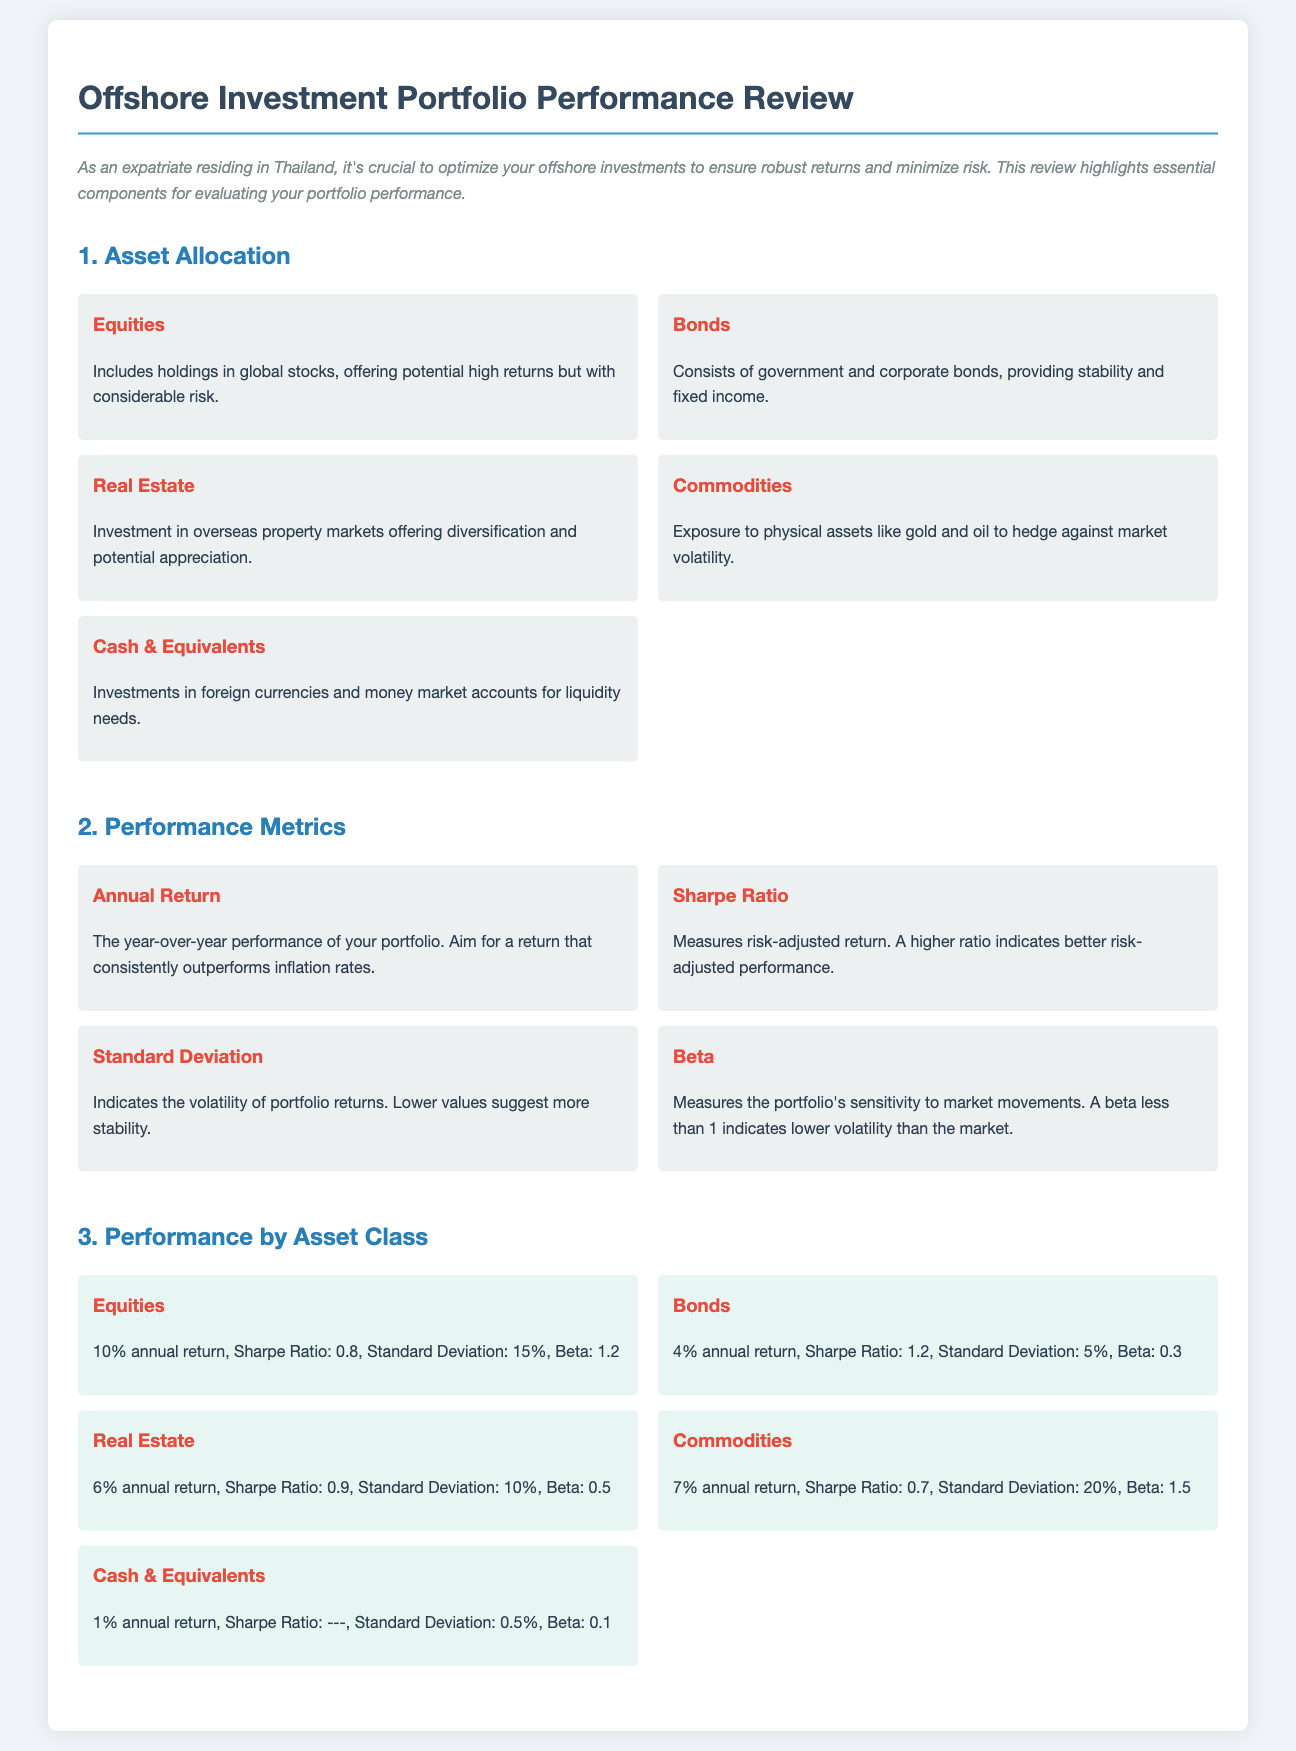What are the top two asset classes by annual return? The top two asset classes by annual return are identified in the performance-by-asset section, with equities at 10% and commodities at 7%.
Answer: Equities, Commodities What is the Sharpe Ratio for Bonds? The Sharpe Ratio for Bonds is listed in the performance-by-asset section, indicating how well returns compensate for risk.
Answer: 1.2 What is the Standard Deviation of Commodities? The Standard Deviation for Commodities is presented as a measure of its volatility in returns, which is noted in the performance-by-asset section.
Answer: 20% Which asset class has the highest Beta? The Beta is included in the performance-by-asset section, where Commodities has the highest value at 1.5.
Answer: Commodities What is the annual return for Cash & Equivalents? The annual return for Cash & Equivalents is found under the performance-by-asset section, summarizing its low yield.
Answer: 1% What measure indicates better risk-adjusted performance? The metric indicative of better risk-adjusted performance is articulated in the performance metrics, focusing on the Sharpe Ratio.
Answer: Sharpe Ratio How many categories are listed under Asset Allocation? The number of asset categories available under Asset Allocation is derived from the asset-allocation section, where five distinct categories are listed.
Answer: 5 What is the purpose of the document? The purpose of the document is conveyed in the introduction, stating it aims to optimize offshore investments for robust returns and minimized risk.
Answer: Optimize offshore investments What is the annual return for Real Estate? The annual return for Real Estate can be extracted from the performance-by-asset section, detailing its specific financial performance.
Answer: 6% 